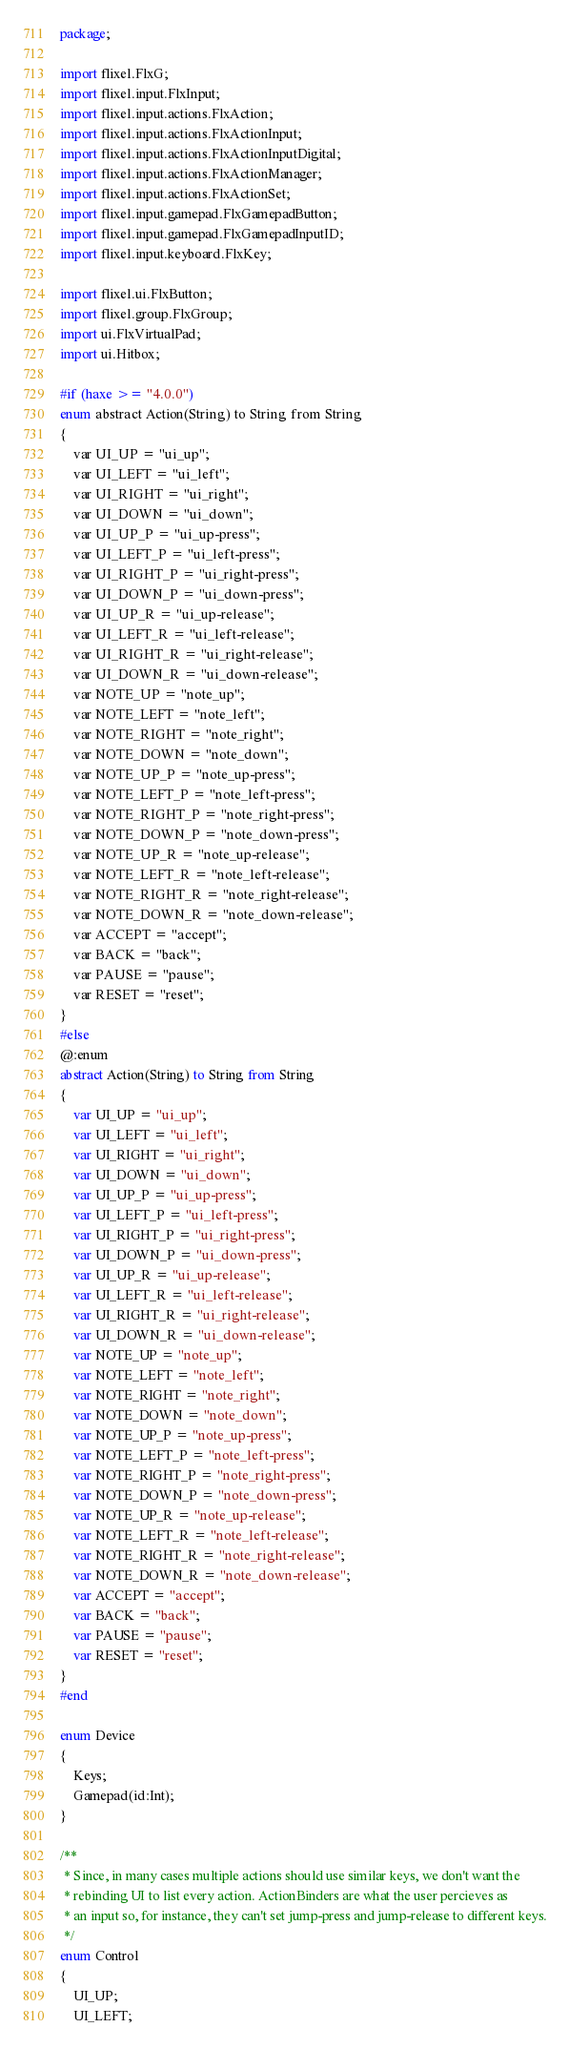Convert code to text. <code><loc_0><loc_0><loc_500><loc_500><_Haxe_>package;

import flixel.FlxG;
import flixel.input.FlxInput;
import flixel.input.actions.FlxAction;
import flixel.input.actions.FlxActionInput;
import flixel.input.actions.FlxActionInputDigital;
import flixel.input.actions.FlxActionManager;
import flixel.input.actions.FlxActionSet;
import flixel.input.gamepad.FlxGamepadButton;
import flixel.input.gamepad.FlxGamepadInputID;
import flixel.input.keyboard.FlxKey;

import flixel.ui.FlxButton;
import flixel.group.FlxGroup;
import ui.FlxVirtualPad;
import ui.Hitbox;

#if (haxe >= "4.0.0")
enum abstract Action(String) to String from String
{
	var UI_UP = "ui_up";
	var UI_LEFT = "ui_left";
	var UI_RIGHT = "ui_right";
	var UI_DOWN = "ui_down";
	var UI_UP_P = "ui_up-press";
	var UI_LEFT_P = "ui_left-press";
	var UI_RIGHT_P = "ui_right-press";
	var UI_DOWN_P = "ui_down-press";
	var UI_UP_R = "ui_up-release";
	var UI_LEFT_R = "ui_left-release";
	var UI_RIGHT_R = "ui_right-release";
	var UI_DOWN_R = "ui_down-release";
	var NOTE_UP = "note_up";
	var NOTE_LEFT = "note_left";
	var NOTE_RIGHT = "note_right";
	var NOTE_DOWN = "note_down";
	var NOTE_UP_P = "note_up-press";
	var NOTE_LEFT_P = "note_left-press";
	var NOTE_RIGHT_P = "note_right-press";
	var NOTE_DOWN_P = "note_down-press";
	var NOTE_UP_R = "note_up-release";
	var NOTE_LEFT_R = "note_left-release";
	var NOTE_RIGHT_R = "note_right-release";
	var NOTE_DOWN_R = "note_down-release";
	var ACCEPT = "accept";
	var BACK = "back";
	var PAUSE = "pause";
	var RESET = "reset";
}
#else
@:enum
abstract Action(String) to String from String
{
	var UI_UP = "ui_up";
	var UI_LEFT = "ui_left";
	var UI_RIGHT = "ui_right";
	var UI_DOWN = "ui_down";
	var UI_UP_P = "ui_up-press";
	var UI_LEFT_P = "ui_left-press";
	var UI_RIGHT_P = "ui_right-press";
	var UI_DOWN_P = "ui_down-press";
	var UI_UP_R = "ui_up-release";
	var UI_LEFT_R = "ui_left-release";
	var UI_RIGHT_R = "ui_right-release";
	var UI_DOWN_R = "ui_down-release";
	var NOTE_UP = "note_up";
	var NOTE_LEFT = "note_left";
	var NOTE_RIGHT = "note_right";
	var NOTE_DOWN = "note_down";
	var NOTE_UP_P = "note_up-press";
	var NOTE_LEFT_P = "note_left-press";
	var NOTE_RIGHT_P = "note_right-press";
	var NOTE_DOWN_P = "note_down-press";
	var NOTE_UP_R = "note_up-release";
	var NOTE_LEFT_R = "note_left-release";
	var NOTE_RIGHT_R = "note_right-release";
	var NOTE_DOWN_R = "note_down-release";
	var ACCEPT = "accept";
	var BACK = "back";
	var PAUSE = "pause";
	var RESET = "reset";
}
#end

enum Device
{
	Keys;
	Gamepad(id:Int);
}

/**
 * Since, in many cases multiple actions should use similar keys, we don't want the
 * rebinding UI to list every action. ActionBinders are what the user percieves as
 * an input so, for instance, they can't set jump-press and jump-release to different keys.
 */
enum Control
{
	UI_UP;
	UI_LEFT;</code> 